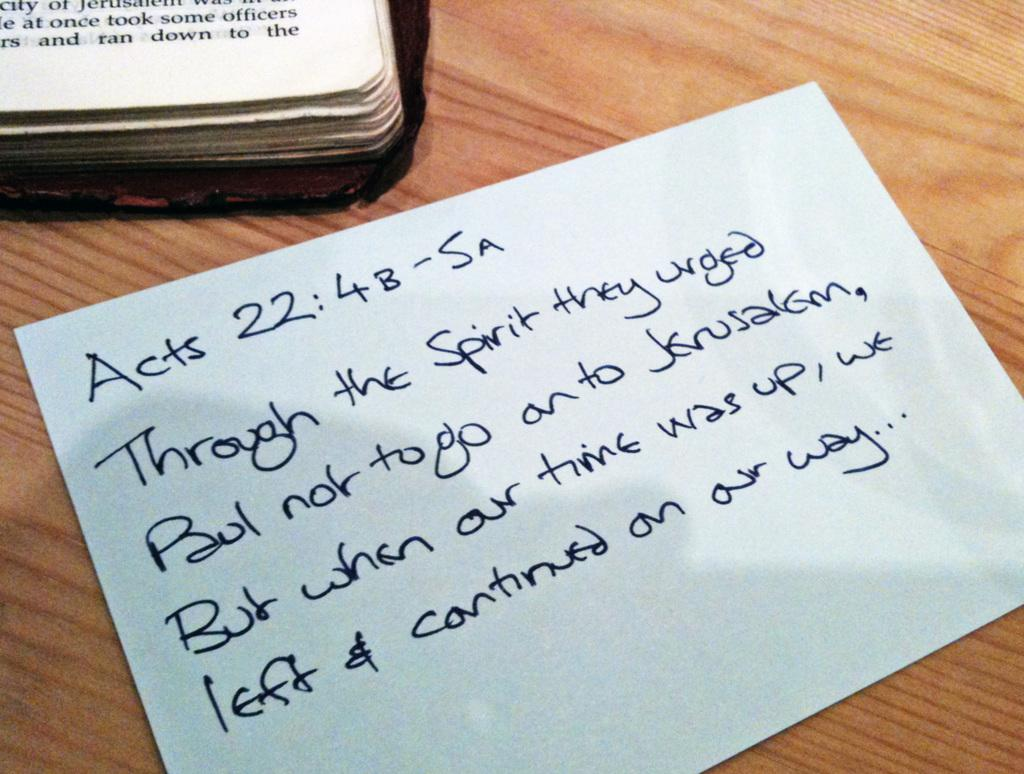<image>
Offer a succinct explanation of the picture presented. the word acts that is on a piece of paper 